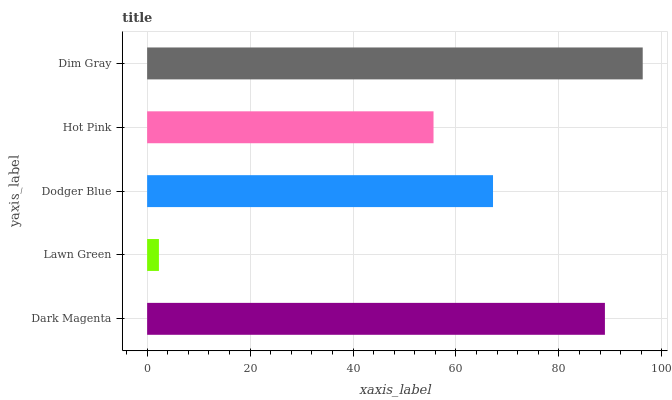Is Lawn Green the minimum?
Answer yes or no. Yes. Is Dim Gray the maximum?
Answer yes or no. Yes. Is Dodger Blue the minimum?
Answer yes or no. No. Is Dodger Blue the maximum?
Answer yes or no. No. Is Dodger Blue greater than Lawn Green?
Answer yes or no. Yes. Is Lawn Green less than Dodger Blue?
Answer yes or no. Yes. Is Lawn Green greater than Dodger Blue?
Answer yes or no. No. Is Dodger Blue less than Lawn Green?
Answer yes or no. No. Is Dodger Blue the high median?
Answer yes or no. Yes. Is Dodger Blue the low median?
Answer yes or no. Yes. Is Hot Pink the high median?
Answer yes or no. No. Is Dark Magenta the low median?
Answer yes or no. No. 